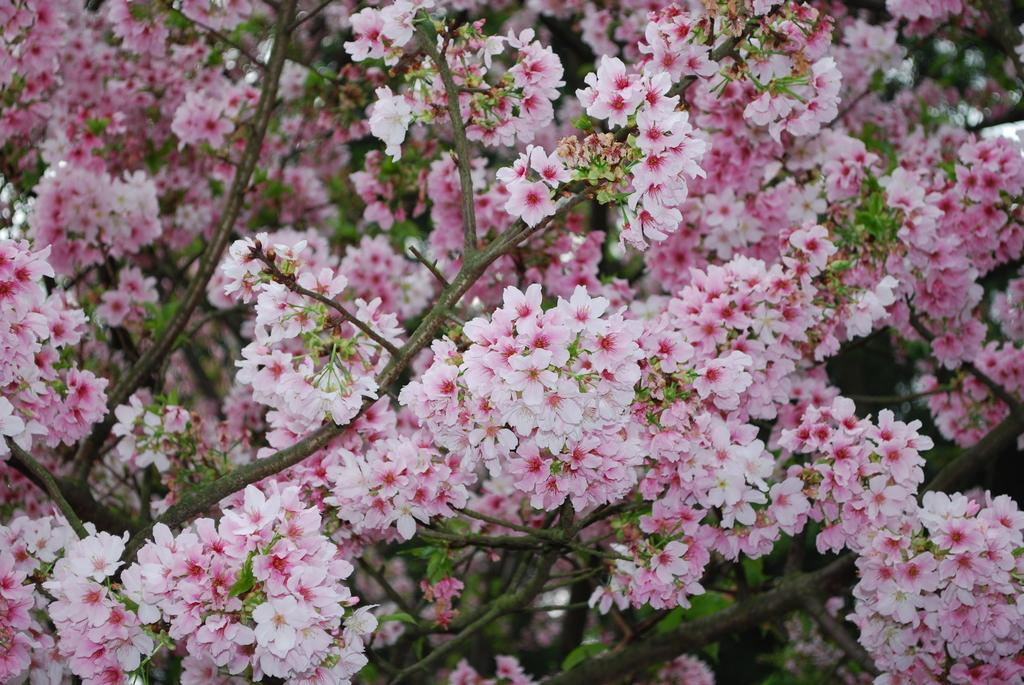What type of plant can be seen in the image? The image contains branches of a tree. What can be found on the branches of the tree? There are flowers and leaves on the branches. What type of sofa can be seen in the garden in the image? There is no sofa or garden present in the image; it only features branches of a tree with flowers and leaves. 